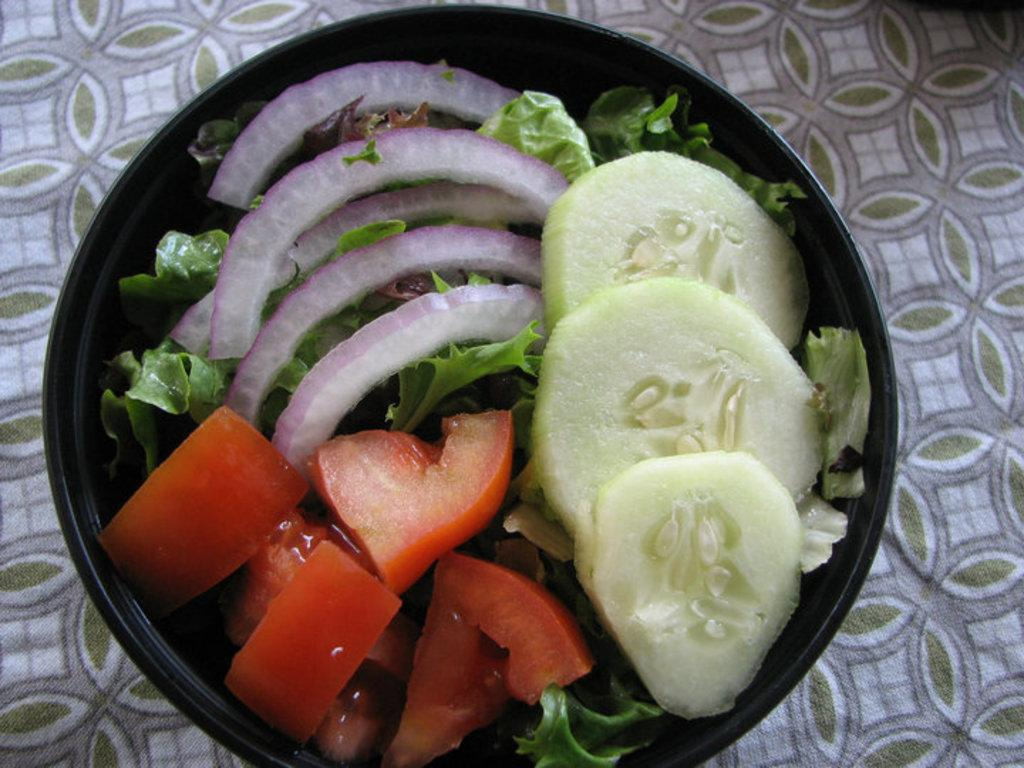What type of vegetables can be seen in the image? There are sliced onions, tomatoes, and cucumbers in the image. What is the overall dish or preparation in the image? There is green salad in the image. How are the vegetables arranged or contained? The vegetables are in a bowl. Where is the bowl located? The bowl is on a table. What type of sail can be seen in the image? There is no sail present in the image; it features vegetables in a bowl on a table. How many holes are visible in the image? There are no holes visible in the image; it features vegetables in a bowl on a table. 